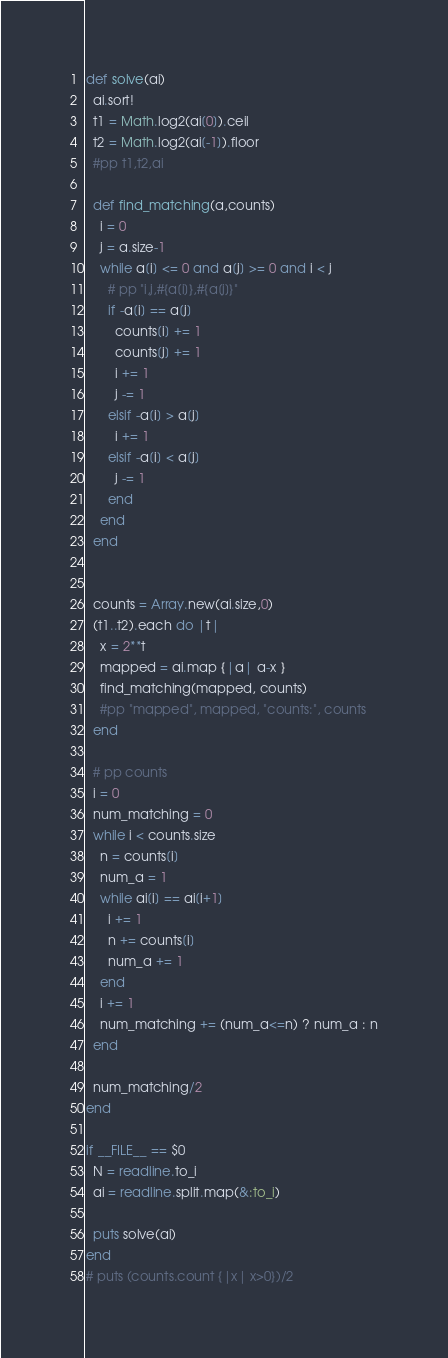<code> <loc_0><loc_0><loc_500><loc_500><_Ruby_>def solve(ai)
  ai.sort!
  t1 = Math.log2(ai[0]).ceil
  t2 = Math.log2(ai[-1]).floor
  #pp t1,t2,ai

  def find_matching(a,counts)
    i = 0
    j = a.size-1
    while a[i] <= 0 and a[j] >= 0 and i < j
      # pp "i,j,#{a[i]},#{a[j]}"
      if -a[i] == a[j]
        counts[i] += 1
        counts[j] += 1
        i += 1
        j -= 1
      elsif -a[i] > a[j]
        i += 1
      elsif -a[i] < a[j]
        j -= 1
      end
    end
  end


  counts = Array.new(ai.size,0)
  (t1..t2).each do |t|
    x = 2**t
    mapped = ai.map {|a| a-x }
    find_matching(mapped, counts)
    #pp "mapped", mapped, "counts:", counts
  end

  # pp counts
  i = 0
  num_matching = 0
  while i < counts.size
    n = counts[i]
    num_a = 1
    while ai[i] == ai[i+1]
      i += 1
      n += counts[i]
      num_a += 1
    end
    i += 1
    num_matching += (num_a<=n) ? num_a : n
  end

  num_matching/2
end

if __FILE__ == $0
  N = readline.to_i
  ai = readline.split.map(&:to_i)

  puts solve(ai)
end
# puts (counts.count {|x| x>0})/2
</code> 